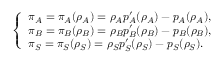<formula> <loc_0><loc_0><loc_500><loc_500>\left \{ \begin{array} { l l } { \pi _ { A } = \pi _ { A } ( \rho _ { A } ) = \rho _ { A } p _ { A } ^ { \prime } ( \rho _ { A } ) - p _ { A } ( \rho _ { A } ) , } \\ { \pi _ { B } = \pi _ { B } ( \rho _ { B } ) = \rho _ { B } p _ { B } ^ { \prime } ( \rho _ { B } ) - p _ { B } ( \rho _ { B } ) , } \\ { \pi _ { S } = \pi _ { S } ( \rho _ { S } ) = \rho _ { S } p _ { S } ^ { \prime } ( \rho _ { S } ) - p _ { S } ( \rho _ { S } ) . } \end{array}</formula> 